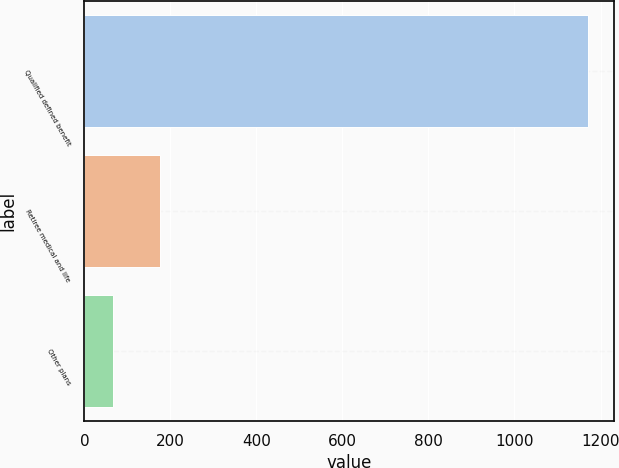<chart> <loc_0><loc_0><loc_500><loc_500><bar_chart><fcel>Qualified defined benefit<fcel>Retiree medical and life<fcel>Other plans<nl><fcel>1172<fcel>176.6<fcel>66<nl></chart> 